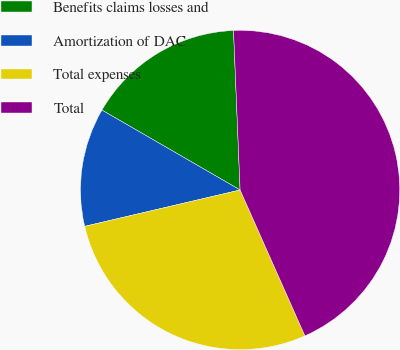Convert chart to OTSL. <chart><loc_0><loc_0><loc_500><loc_500><pie_chart><fcel>Benefits claims losses and<fcel>Amortization of DAC<fcel>Total expenses<fcel>Total<nl><fcel>16.0%<fcel>12.0%<fcel>28.0%<fcel>44.0%<nl></chart> 